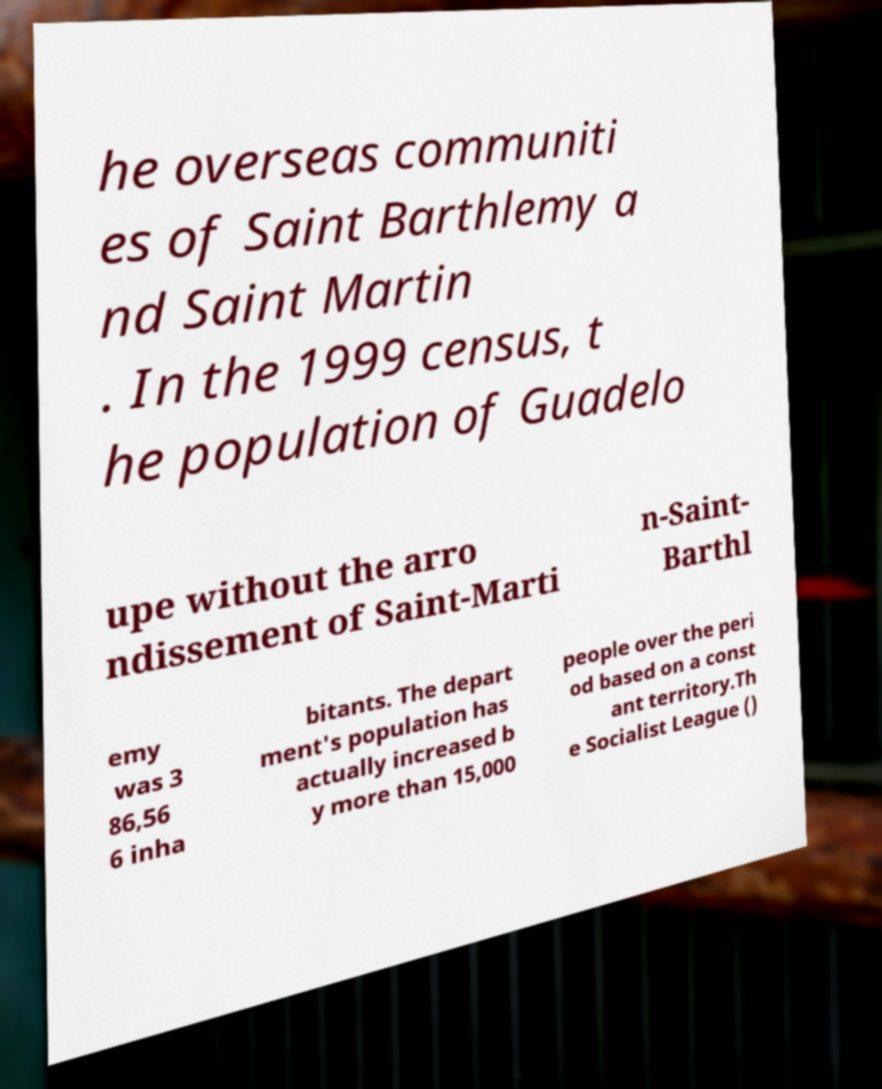Please read and relay the text visible in this image. What does it say? he overseas communiti es of Saint Barthlemy a nd Saint Martin . In the 1999 census, t he population of Guadelo upe without the arro ndissement of Saint-Marti n-Saint- Barthl emy was 3 86,56 6 inha bitants. The depart ment's population has actually increased b y more than 15,000 people over the peri od based on a const ant territory.Th e Socialist League () 